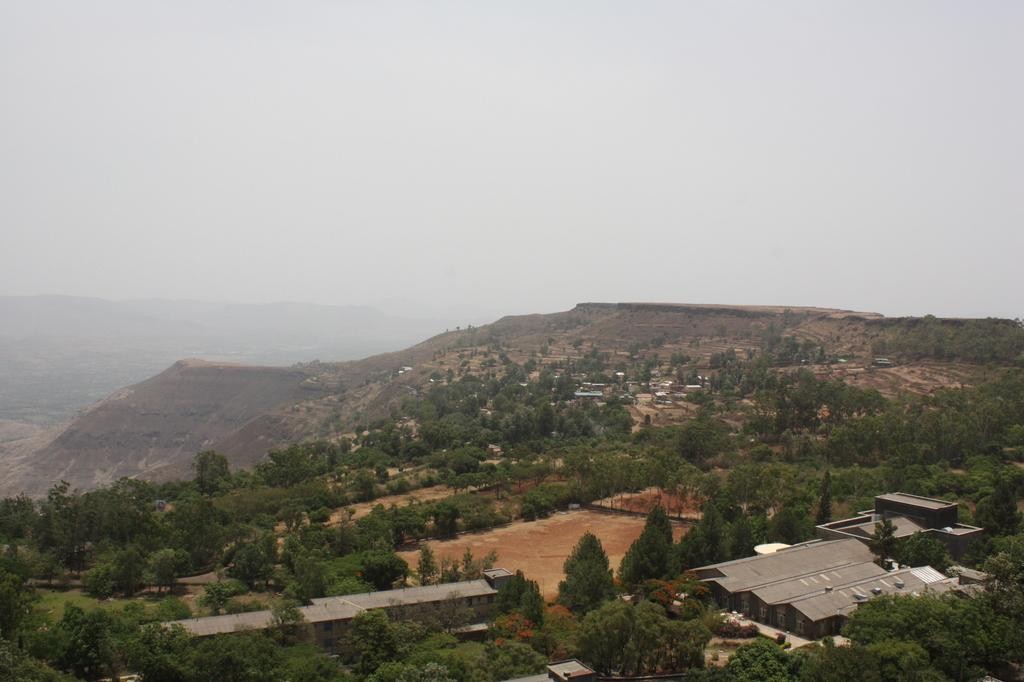What type of structure is present in the image? There is a building in the image. What natural elements can be seen in the image? There are trees and mountains in the image. What part of the environment is visible in the image? The sky is visible in the image. What color is the blood on the knee in the image? There is no blood or knee present in the image. 